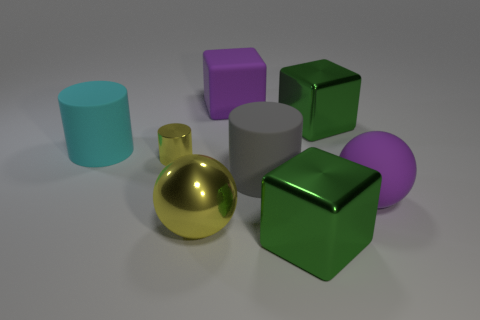Does the big matte block have the same color as the large rubber sphere? yes 